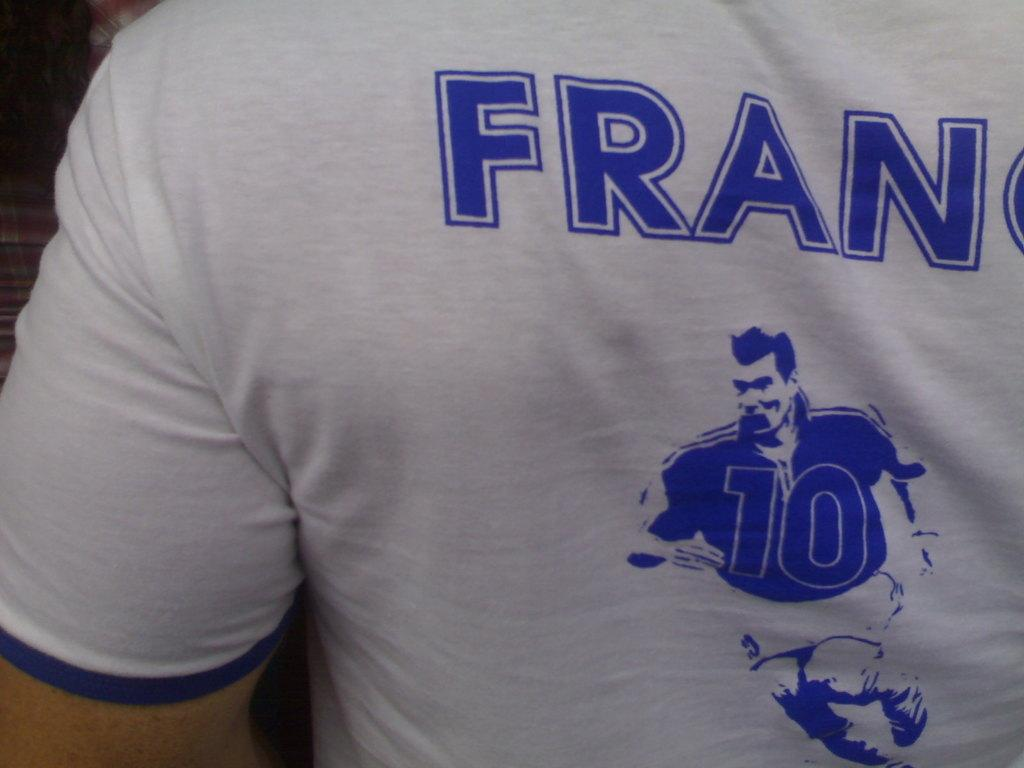<image>
Give a short and clear explanation of the subsequent image. A t-shirt depicting a football player with the number 10 on the front of the jersey 